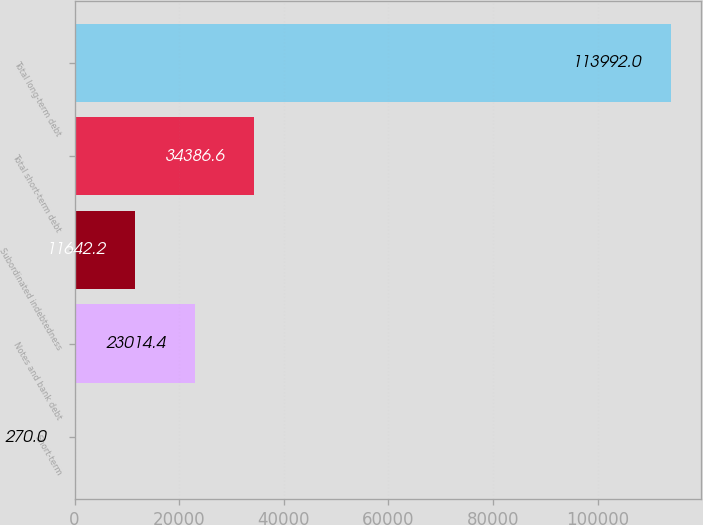<chart> <loc_0><loc_0><loc_500><loc_500><bar_chart><fcel>Short-term<fcel>Notes and bank debt<fcel>Subordinated indebtedness<fcel>Total short-term debt<fcel>Total long-term debt<nl><fcel>270<fcel>23014.4<fcel>11642.2<fcel>34386.6<fcel>113992<nl></chart> 